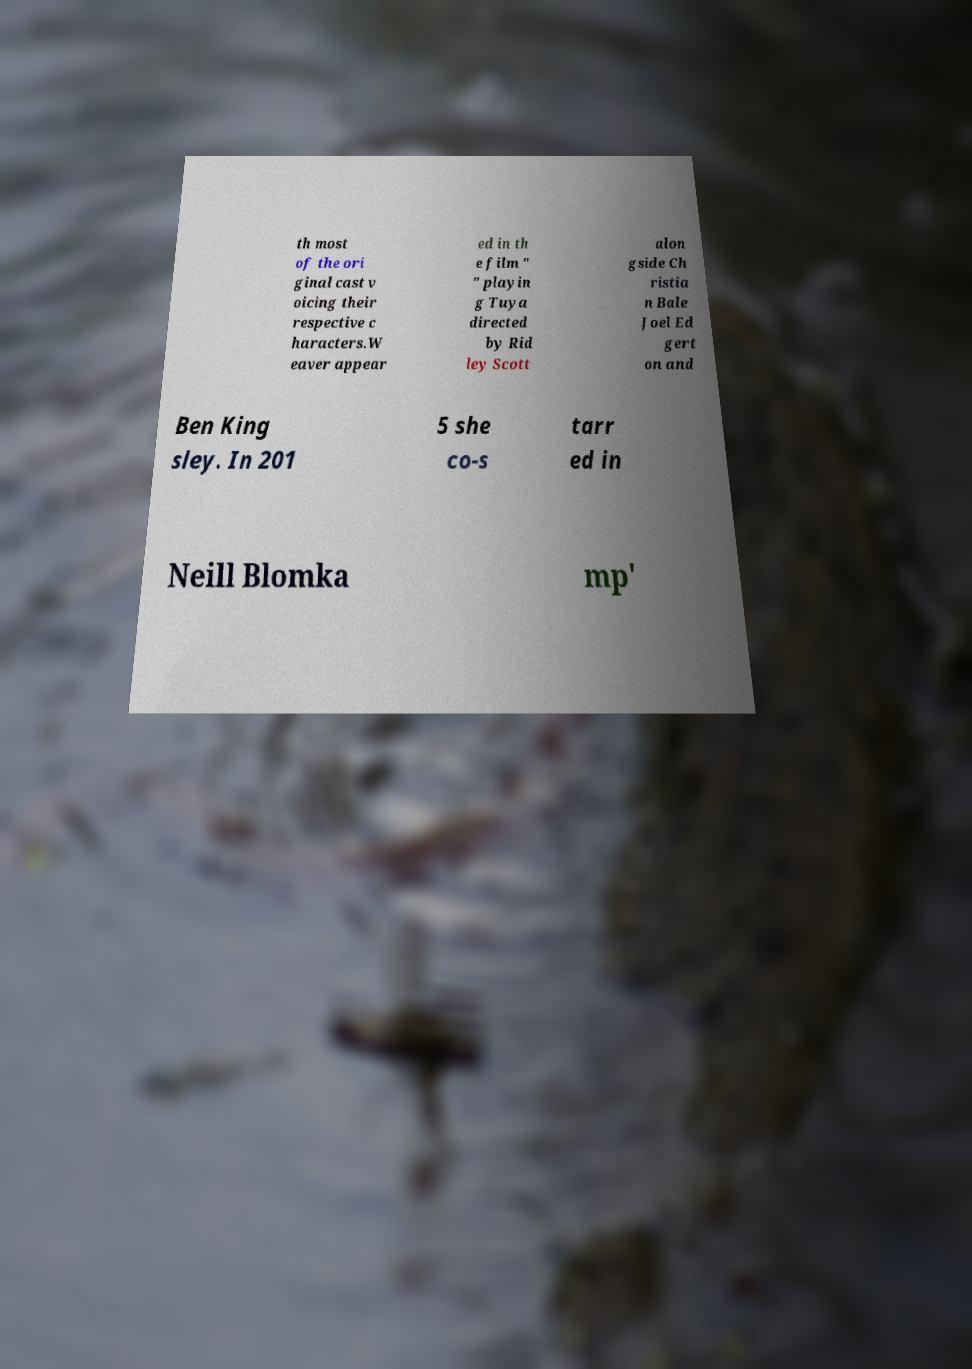Please identify and transcribe the text found in this image. th most of the ori ginal cast v oicing their respective c haracters.W eaver appear ed in th e film " " playin g Tuya directed by Rid ley Scott alon gside Ch ristia n Bale Joel Ed gert on and Ben King sley. In 201 5 she co-s tarr ed in Neill Blomka mp' 